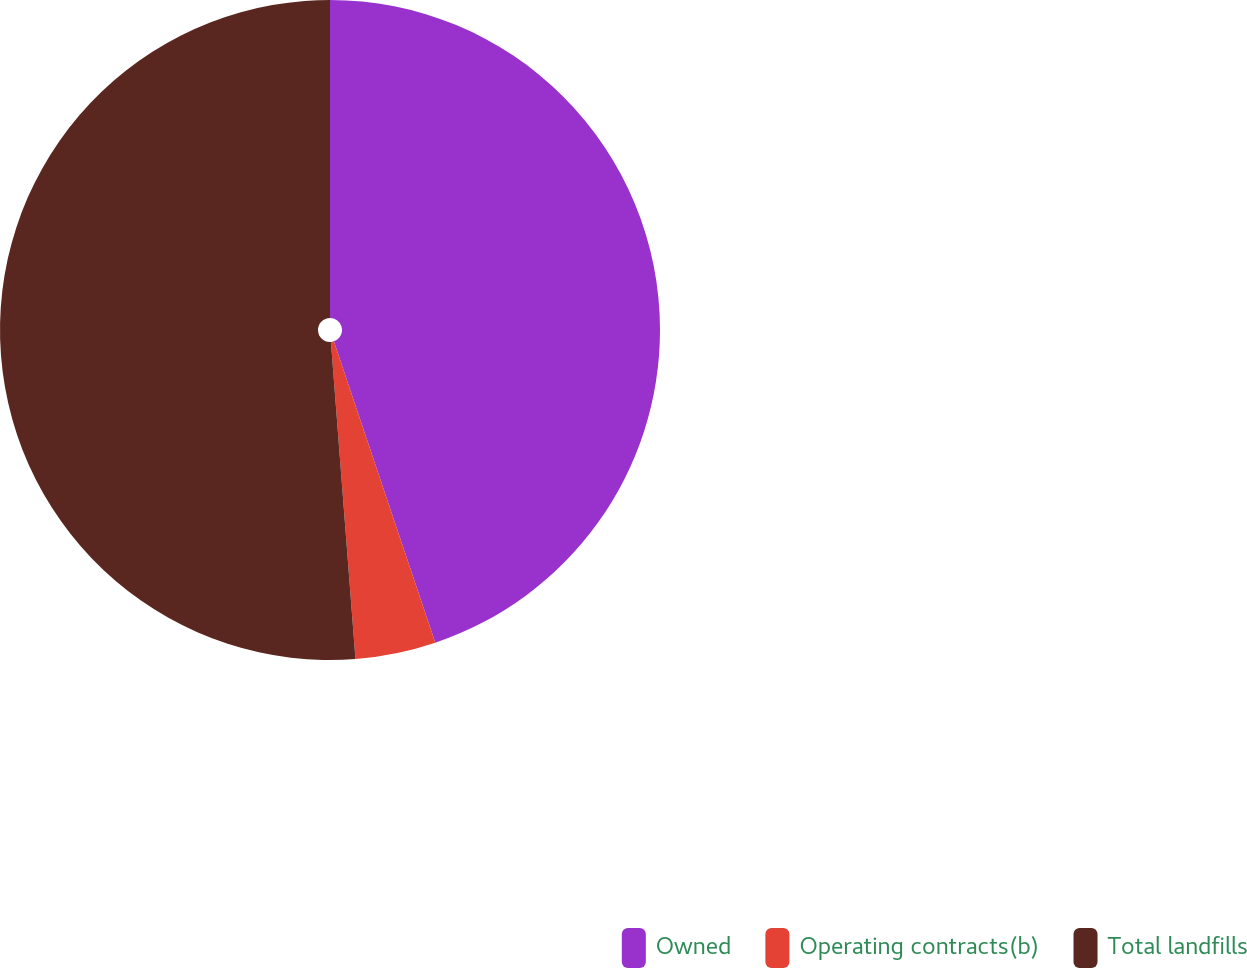Convert chart to OTSL. <chart><loc_0><loc_0><loc_500><loc_500><pie_chart><fcel>Owned<fcel>Operating contracts(b)<fcel>Total landfills<nl><fcel>44.83%<fcel>3.94%<fcel>51.23%<nl></chart> 